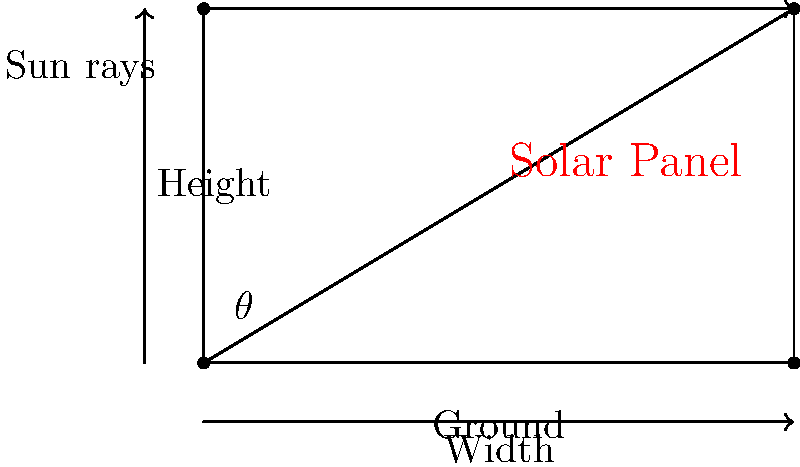A Chicago homeowner wants to install solar panels on their flat rooftop to maximize energy efficiency. The optimal angle for solar panels in Chicago is approximately 35° from the horizontal. If the width of the solar panel is 5 feet, what is the height of the panel's elevated end to achieve this optimal angle? To solve this problem, we'll use trigonometry:

1) In a right triangle, tangent of an angle is the ratio of the opposite side to the adjacent side.

2) In this case:
   - The angle $\theta$ is 35°
   - The adjacent side (width) is 5 feet
   - We need to find the opposite side (height)

3) We can use the tangent function:

   $$\tan(\theta) = \frac{\text{opposite}}{\text{adjacent}} = \frac{\text{height}}{\text{width}}$$

4) Rearranging the equation:

   $$\text{height} = \text{width} \times \tan(\theta)$$

5) Plugging in the values:

   $$\text{height} = 5 \times \tan(35°)$$

6) Using a calculator or trigonometric table:

   $$\text{height} = 5 \times 0.7002 = 3.501 \text{ feet}$$

7) Rounding to two decimal places:

   $$\text{height} \approx 3.50 \text{ feet}$$
Answer: 3.50 feet 